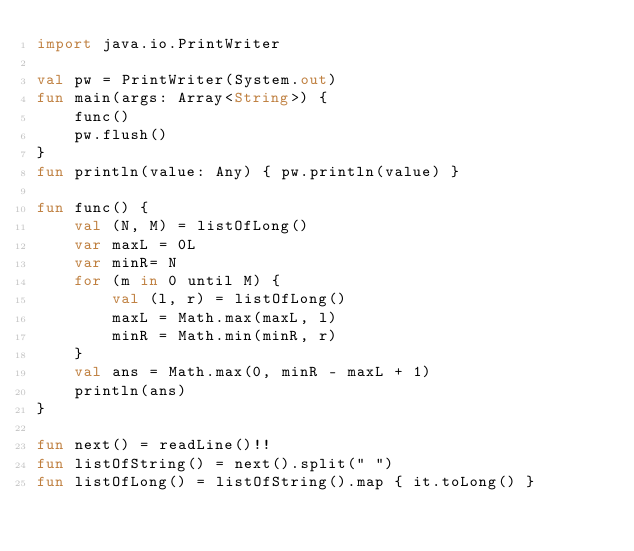Convert code to text. <code><loc_0><loc_0><loc_500><loc_500><_Kotlin_>import java.io.PrintWriter

val pw = PrintWriter(System.out)
fun main(args: Array<String>) {
    func()
    pw.flush()
}
fun println(value: Any) { pw.println(value) }

fun func() {
    val (N, M) = listOfLong()
    var maxL = 0L
    var minR= N
    for (m in 0 until M) {
        val (l, r) = listOfLong()
        maxL = Math.max(maxL, l)
        minR = Math.min(minR, r)
    }
    val ans = Math.max(0, minR - maxL + 1)
    println(ans)
}

fun next() = readLine()!!
fun listOfString() = next().split(" ")
fun listOfLong() = listOfString().map { it.toLong() }
</code> 